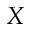Convert formula to latex. <formula><loc_0><loc_0><loc_500><loc_500>X</formula> 